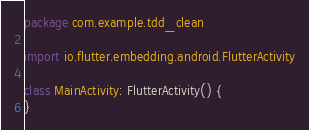Convert code to text. <code><loc_0><loc_0><loc_500><loc_500><_Kotlin_>package com.example.tdd_clean

import io.flutter.embedding.android.FlutterActivity

class MainActivity: FlutterActivity() {
}
</code> 